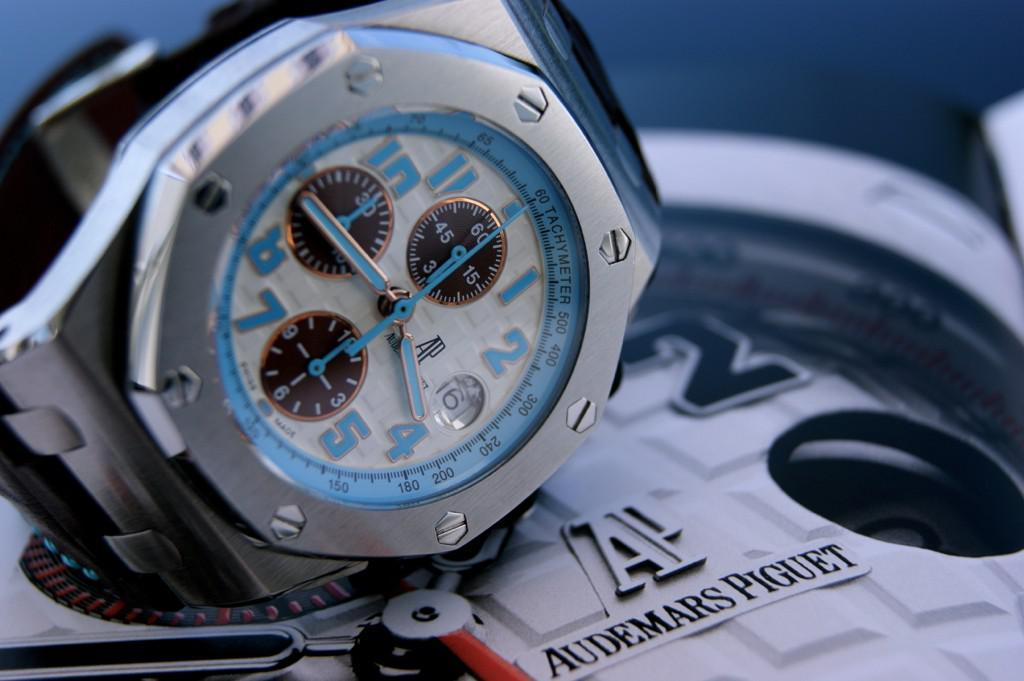Provide a one-sentence caption for the provided image. A watch sits on a larger watch by Audemars Piguet. 